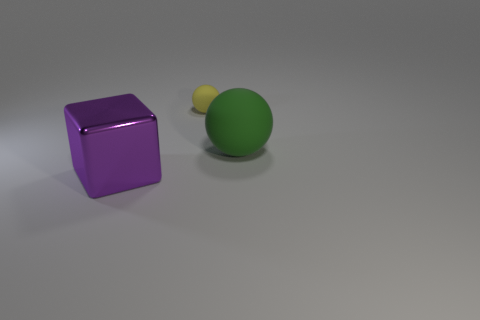There is another rubber object that is the same shape as the green object; what is its color?
Offer a very short reply. Yellow. How many things are either balls in front of the yellow thing or rubber spheres that are behind the large matte sphere?
Make the answer very short. 2. What shape is the purple metal object?
Make the answer very short. Cube. What number of large purple objects have the same material as the purple cube?
Your answer should be very brief. 0. What color is the shiny thing?
Make the answer very short. Purple. There is a metallic cube that is the same size as the green sphere; what color is it?
Ensure brevity in your answer.  Purple. Is the shape of the big object to the right of the purple metallic thing the same as the thing behind the big ball?
Your response must be concise. Yes. How many other things are the same size as the purple metal block?
Keep it short and to the point. 1. Are there fewer cubes that are left of the tiny rubber sphere than things left of the green ball?
Give a very brief answer. Yes. What color is the thing that is both in front of the yellow matte sphere and to the left of the green matte sphere?
Keep it short and to the point. Purple. 